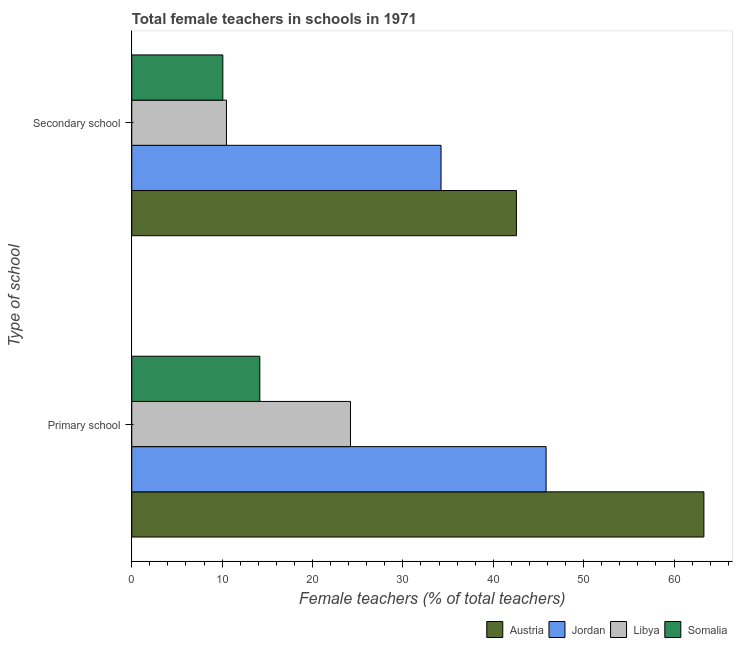How many different coloured bars are there?
Offer a terse response. 4. Are the number of bars on each tick of the Y-axis equal?
Your answer should be compact. Yes. How many bars are there on the 1st tick from the top?
Provide a short and direct response. 4. What is the label of the 1st group of bars from the top?
Offer a very short reply. Secondary school. What is the percentage of female teachers in secondary schools in Somalia?
Provide a short and direct response. 10.08. Across all countries, what is the maximum percentage of female teachers in primary schools?
Offer a very short reply. 63.3. Across all countries, what is the minimum percentage of female teachers in secondary schools?
Provide a succinct answer. 10.08. In which country was the percentage of female teachers in secondary schools maximum?
Provide a succinct answer. Austria. In which country was the percentage of female teachers in secondary schools minimum?
Your answer should be compact. Somalia. What is the total percentage of female teachers in secondary schools in the graph?
Your answer should be very brief. 97.34. What is the difference between the percentage of female teachers in primary schools in Austria and that in Somalia?
Give a very brief answer. 49.14. What is the difference between the percentage of female teachers in primary schools in Austria and the percentage of female teachers in secondary schools in Libya?
Provide a short and direct response. 52.83. What is the average percentage of female teachers in primary schools per country?
Make the answer very short. 36.88. What is the difference between the percentage of female teachers in secondary schools and percentage of female teachers in primary schools in Austria?
Give a very brief answer. -20.74. In how many countries, is the percentage of female teachers in primary schools greater than 42 %?
Your answer should be compact. 2. What is the ratio of the percentage of female teachers in primary schools in Austria to that in Libya?
Ensure brevity in your answer.  2.62. Is the percentage of female teachers in secondary schools in Somalia less than that in Libya?
Provide a short and direct response. Yes. In how many countries, is the percentage of female teachers in primary schools greater than the average percentage of female teachers in primary schools taken over all countries?
Give a very brief answer. 2. What does the 4th bar from the bottom in Secondary school represents?
Your response must be concise. Somalia. How many bars are there?
Your answer should be very brief. 8. How many countries are there in the graph?
Provide a short and direct response. 4. Where does the legend appear in the graph?
Keep it short and to the point. Bottom right. How are the legend labels stacked?
Ensure brevity in your answer.  Horizontal. What is the title of the graph?
Provide a short and direct response. Total female teachers in schools in 1971. Does "Guinea-Bissau" appear as one of the legend labels in the graph?
Your answer should be compact. No. What is the label or title of the X-axis?
Your answer should be very brief. Female teachers (% of total teachers). What is the label or title of the Y-axis?
Your answer should be compact. Type of school. What is the Female teachers (% of total teachers) of Austria in Primary school?
Provide a short and direct response. 63.3. What is the Female teachers (% of total teachers) in Jordan in Primary school?
Make the answer very short. 45.85. What is the Female teachers (% of total teachers) in Libya in Primary school?
Your response must be concise. 24.2. What is the Female teachers (% of total teachers) in Somalia in Primary school?
Your answer should be compact. 14.17. What is the Female teachers (% of total teachers) of Austria in Secondary school?
Provide a succinct answer. 42.56. What is the Female teachers (% of total teachers) in Jordan in Secondary school?
Offer a very short reply. 34.22. What is the Female teachers (% of total teachers) of Libya in Secondary school?
Provide a short and direct response. 10.48. What is the Female teachers (% of total teachers) of Somalia in Secondary school?
Provide a succinct answer. 10.08. Across all Type of school, what is the maximum Female teachers (% of total teachers) of Austria?
Offer a terse response. 63.3. Across all Type of school, what is the maximum Female teachers (% of total teachers) in Jordan?
Offer a terse response. 45.85. Across all Type of school, what is the maximum Female teachers (% of total teachers) of Libya?
Make the answer very short. 24.2. Across all Type of school, what is the maximum Female teachers (% of total teachers) in Somalia?
Give a very brief answer. 14.17. Across all Type of school, what is the minimum Female teachers (% of total teachers) of Austria?
Keep it short and to the point. 42.56. Across all Type of school, what is the minimum Female teachers (% of total teachers) of Jordan?
Your answer should be compact. 34.22. Across all Type of school, what is the minimum Female teachers (% of total teachers) in Libya?
Your answer should be very brief. 10.48. Across all Type of school, what is the minimum Female teachers (% of total teachers) of Somalia?
Keep it short and to the point. 10.08. What is the total Female teachers (% of total teachers) of Austria in the graph?
Provide a succinct answer. 105.87. What is the total Female teachers (% of total teachers) in Jordan in the graph?
Offer a terse response. 80.07. What is the total Female teachers (% of total teachers) of Libya in the graph?
Your response must be concise. 34.68. What is the total Female teachers (% of total teachers) in Somalia in the graph?
Make the answer very short. 24.25. What is the difference between the Female teachers (% of total teachers) of Austria in Primary school and that in Secondary school?
Give a very brief answer. 20.74. What is the difference between the Female teachers (% of total teachers) of Jordan in Primary school and that in Secondary school?
Ensure brevity in your answer.  11.63. What is the difference between the Female teachers (% of total teachers) of Libya in Primary school and that in Secondary school?
Keep it short and to the point. 13.73. What is the difference between the Female teachers (% of total teachers) of Somalia in Primary school and that in Secondary school?
Offer a very short reply. 4.09. What is the difference between the Female teachers (% of total teachers) in Austria in Primary school and the Female teachers (% of total teachers) in Jordan in Secondary school?
Provide a succinct answer. 29.09. What is the difference between the Female teachers (% of total teachers) in Austria in Primary school and the Female teachers (% of total teachers) in Libya in Secondary school?
Give a very brief answer. 52.83. What is the difference between the Female teachers (% of total teachers) in Austria in Primary school and the Female teachers (% of total teachers) in Somalia in Secondary school?
Make the answer very short. 53.23. What is the difference between the Female teachers (% of total teachers) in Jordan in Primary school and the Female teachers (% of total teachers) in Libya in Secondary school?
Ensure brevity in your answer.  35.37. What is the difference between the Female teachers (% of total teachers) of Jordan in Primary school and the Female teachers (% of total teachers) of Somalia in Secondary school?
Keep it short and to the point. 35.77. What is the difference between the Female teachers (% of total teachers) of Libya in Primary school and the Female teachers (% of total teachers) of Somalia in Secondary school?
Your answer should be compact. 14.13. What is the average Female teachers (% of total teachers) in Austria per Type of school?
Your response must be concise. 52.93. What is the average Female teachers (% of total teachers) of Jordan per Type of school?
Give a very brief answer. 40.03. What is the average Female teachers (% of total teachers) of Libya per Type of school?
Your answer should be very brief. 17.34. What is the average Female teachers (% of total teachers) of Somalia per Type of school?
Offer a very short reply. 12.12. What is the difference between the Female teachers (% of total teachers) of Austria and Female teachers (% of total teachers) of Jordan in Primary school?
Make the answer very short. 17.46. What is the difference between the Female teachers (% of total teachers) of Austria and Female teachers (% of total teachers) of Libya in Primary school?
Ensure brevity in your answer.  39.1. What is the difference between the Female teachers (% of total teachers) of Austria and Female teachers (% of total teachers) of Somalia in Primary school?
Your answer should be compact. 49.14. What is the difference between the Female teachers (% of total teachers) of Jordan and Female teachers (% of total teachers) of Libya in Primary school?
Offer a very short reply. 21.64. What is the difference between the Female teachers (% of total teachers) of Jordan and Female teachers (% of total teachers) of Somalia in Primary school?
Your answer should be compact. 31.68. What is the difference between the Female teachers (% of total teachers) in Libya and Female teachers (% of total teachers) in Somalia in Primary school?
Ensure brevity in your answer.  10.03. What is the difference between the Female teachers (% of total teachers) of Austria and Female teachers (% of total teachers) of Jordan in Secondary school?
Offer a terse response. 8.34. What is the difference between the Female teachers (% of total teachers) of Austria and Female teachers (% of total teachers) of Libya in Secondary school?
Your answer should be compact. 32.09. What is the difference between the Female teachers (% of total teachers) of Austria and Female teachers (% of total teachers) of Somalia in Secondary school?
Your answer should be compact. 32.48. What is the difference between the Female teachers (% of total teachers) of Jordan and Female teachers (% of total teachers) of Libya in Secondary school?
Provide a short and direct response. 23.74. What is the difference between the Female teachers (% of total teachers) of Jordan and Female teachers (% of total teachers) of Somalia in Secondary school?
Provide a succinct answer. 24.14. What is the difference between the Female teachers (% of total teachers) of Libya and Female teachers (% of total teachers) of Somalia in Secondary school?
Your answer should be very brief. 0.4. What is the ratio of the Female teachers (% of total teachers) of Austria in Primary school to that in Secondary school?
Your answer should be compact. 1.49. What is the ratio of the Female teachers (% of total teachers) of Jordan in Primary school to that in Secondary school?
Your response must be concise. 1.34. What is the ratio of the Female teachers (% of total teachers) of Libya in Primary school to that in Secondary school?
Ensure brevity in your answer.  2.31. What is the ratio of the Female teachers (% of total teachers) of Somalia in Primary school to that in Secondary school?
Ensure brevity in your answer.  1.41. What is the difference between the highest and the second highest Female teachers (% of total teachers) of Austria?
Provide a short and direct response. 20.74. What is the difference between the highest and the second highest Female teachers (% of total teachers) of Jordan?
Offer a very short reply. 11.63. What is the difference between the highest and the second highest Female teachers (% of total teachers) in Libya?
Keep it short and to the point. 13.73. What is the difference between the highest and the second highest Female teachers (% of total teachers) of Somalia?
Provide a succinct answer. 4.09. What is the difference between the highest and the lowest Female teachers (% of total teachers) of Austria?
Make the answer very short. 20.74. What is the difference between the highest and the lowest Female teachers (% of total teachers) in Jordan?
Provide a short and direct response. 11.63. What is the difference between the highest and the lowest Female teachers (% of total teachers) in Libya?
Ensure brevity in your answer.  13.73. What is the difference between the highest and the lowest Female teachers (% of total teachers) in Somalia?
Give a very brief answer. 4.09. 